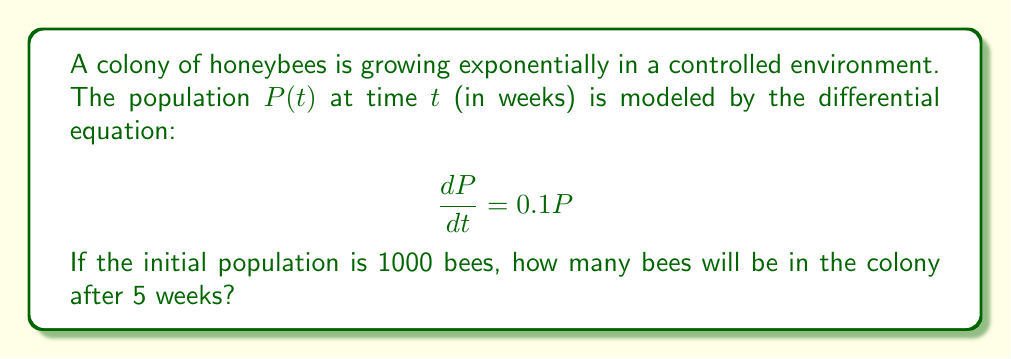Solve this math problem. Let's solve this step-by-step:

1) The given differential equation is:
   $$\frac{dP}{dt} = 0.1P$$

2) This is a separable differential equation. We can rewrite it as:
   $$\frac{dP}{P} = 0.1dt$$

3) Integrating both sides:
   $$\int \frac{dP}{P} = \int 0.1dt$$
   $$\ln|P| = 0.1t + C$$

4) Solving for $P$:
   $$P = e^{0.1t + C} = e^C \cdot e^{0.1t}$$

5) Let $A = e^C$. Then our general solution is:
   $$P(t) = Ae^{0.1t}$$

6) Using the initial condition $P(0) = 1000$:
   $$1000 = Ae^{0 \cdot 0.1} = A$$

7) So our particular solution is:
   $$P(t) = 1000e^{0.1t}$$

8) To find the population after 5 weeks, we evaluate $P(5)$:
   $$P(5) = 1000e^{0.1 \cdot 5} = 1000e^{0.5} \approx 1648.72$$

9) Rounding to the nearest whole number (as we can't have fractional bees):
   $$P(5) \approx 1649 \text{ bees}$$
Answer: 1649 bees 